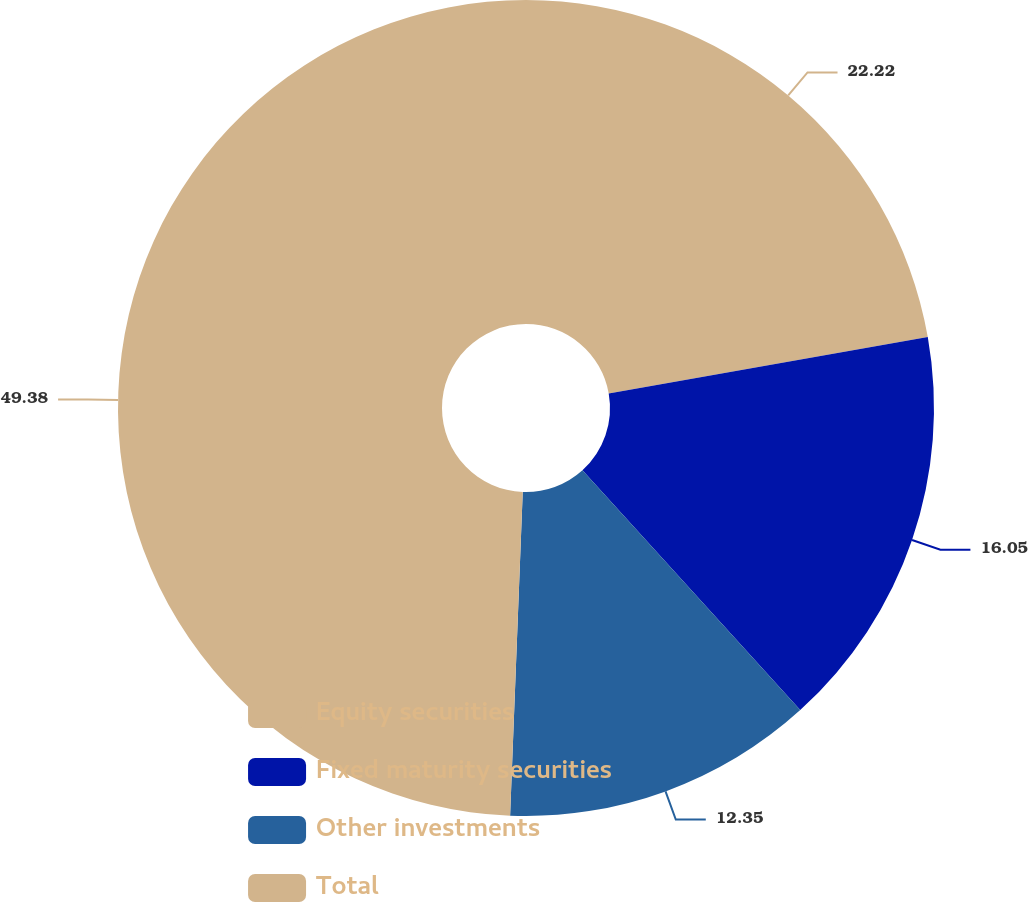Convert chart. <chart><loc_0><loc_0><loc_500><loc_500><pie_chart><fcel>Equity securities<fcel>Fixed maturity securities<fcel>Other investments<fcel>Total<nl><fcel>22.22%<fcel>16.05%<fcel>12.35%<fcel>49.38%<nl></chart> 